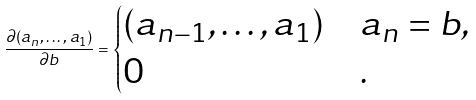Convert formula to latex. <formula><loc_0><loc_0><loc_500><loc_500>\frac { \partial ( a _ { n } , \dots , a _ { 1 } ) } { \partial b } = \begin{cases} ( a _ { n - 1 } , \dots , a _ { 1 } ) & a _ { n } = b , \\ 0 & . \end{cases}</formula> 